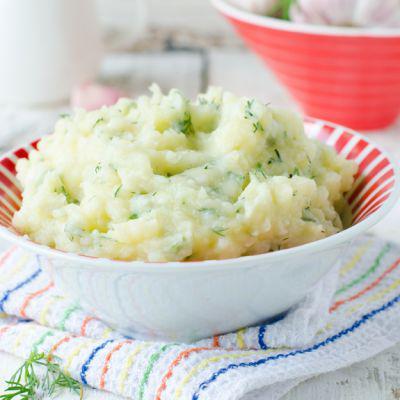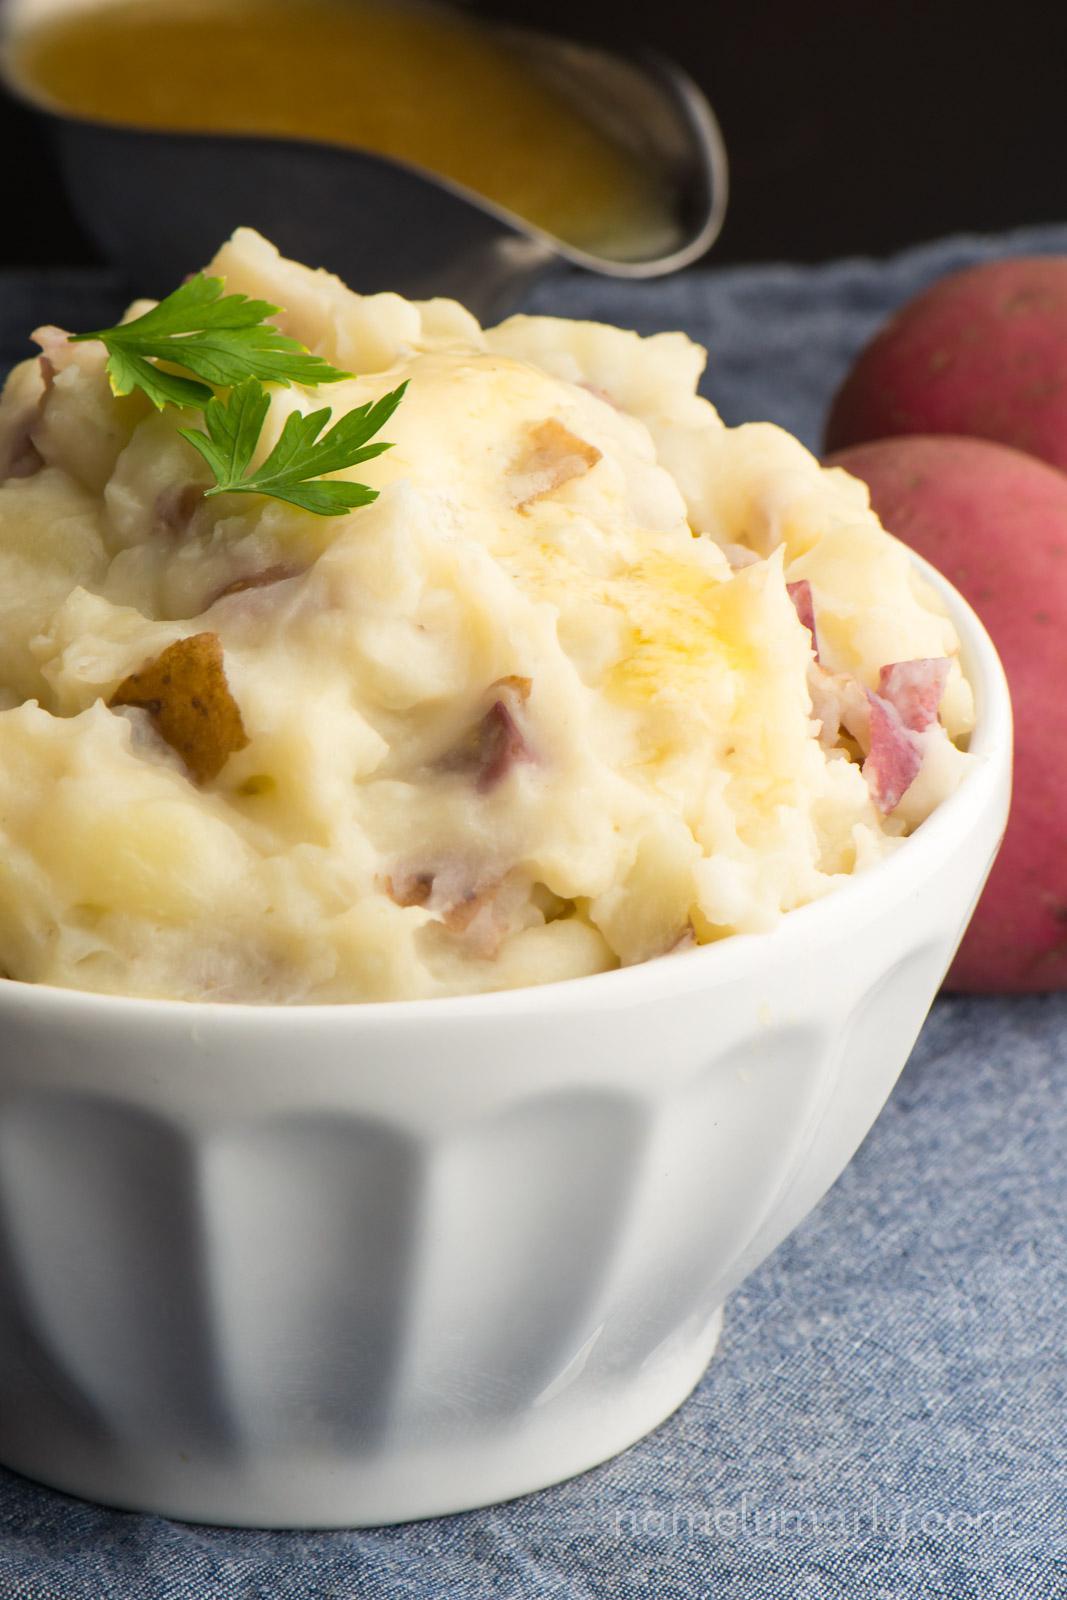The first image is the image on the left, the second image is the image on the right. Evaluate the accuracy of this statement regarding the images: "The mashed potatoes in the right image are inside of a white container.". Is it true? Answer yes or no. Yes. The first image is the image on the left, the second image is the image on the right. For the images displayed, is the sentence "Some of the mashed potatoes are in a green bowl sitting on top of a striped tablecloth." factually correct? Answer yes or no. No. 